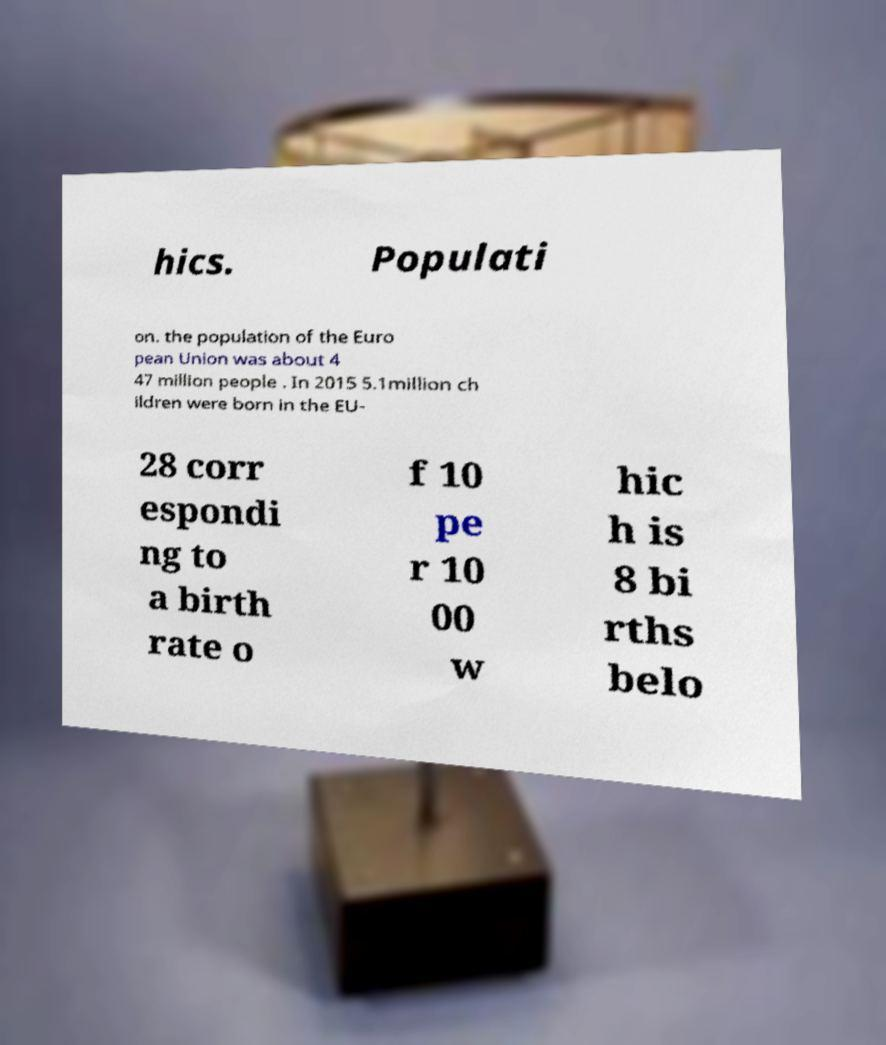I need the written content from this picture converted into text. Can you do that? hics. Populati on. the population of the Euro pean Union was about 4 47 million people . In 2015 5.1million ch ildren were born in the EU- 28 corr espondi ng to a birth rate o f 10 pe r 10 00 w hic h is 8 bi rths belo 